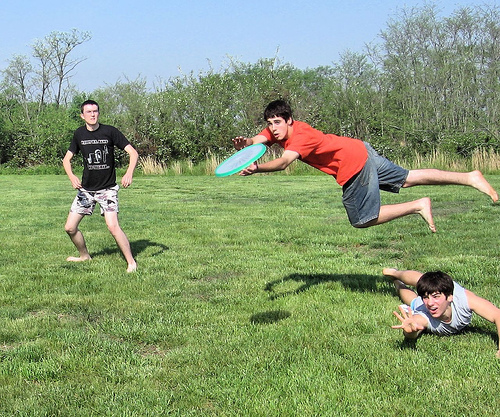Please provide a short description for this region: [0.72, 0.59, 1.0, 0.81]. A person laying in the grass. 